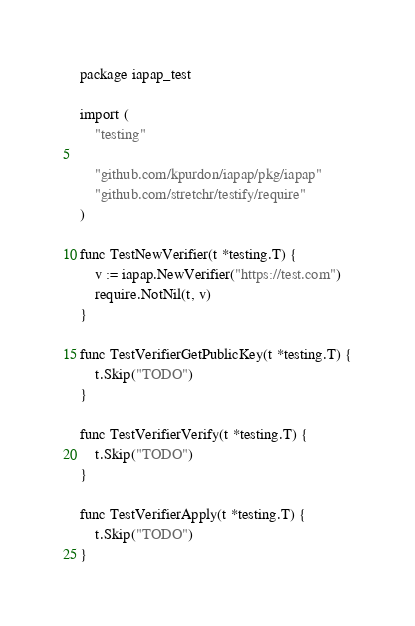Convert code to text. <code><loc_0><loc_0><loc_500><loc_500><_Go_>package iapap_test

import (
	"testing"

	"github.com/kpurdon/iapap/pkg/iapap"
	"github.com/stretchr/testify/require"
)

func TestNewVerifier(t *testing.T) {
	v := iapap.NewVerifier("https://test.com")
	require.NotNil(t, v)
}

func TestVerifierGetPublicKey(t *testing.T) {
	t.Skip("TODO")
}

func TestVerifierVerify(t *testing.T) {
	t.Skip("TODO")
}

func TestVerifierApply(t *testing.T) {
	t.Skip("TODO")
}
</code> 